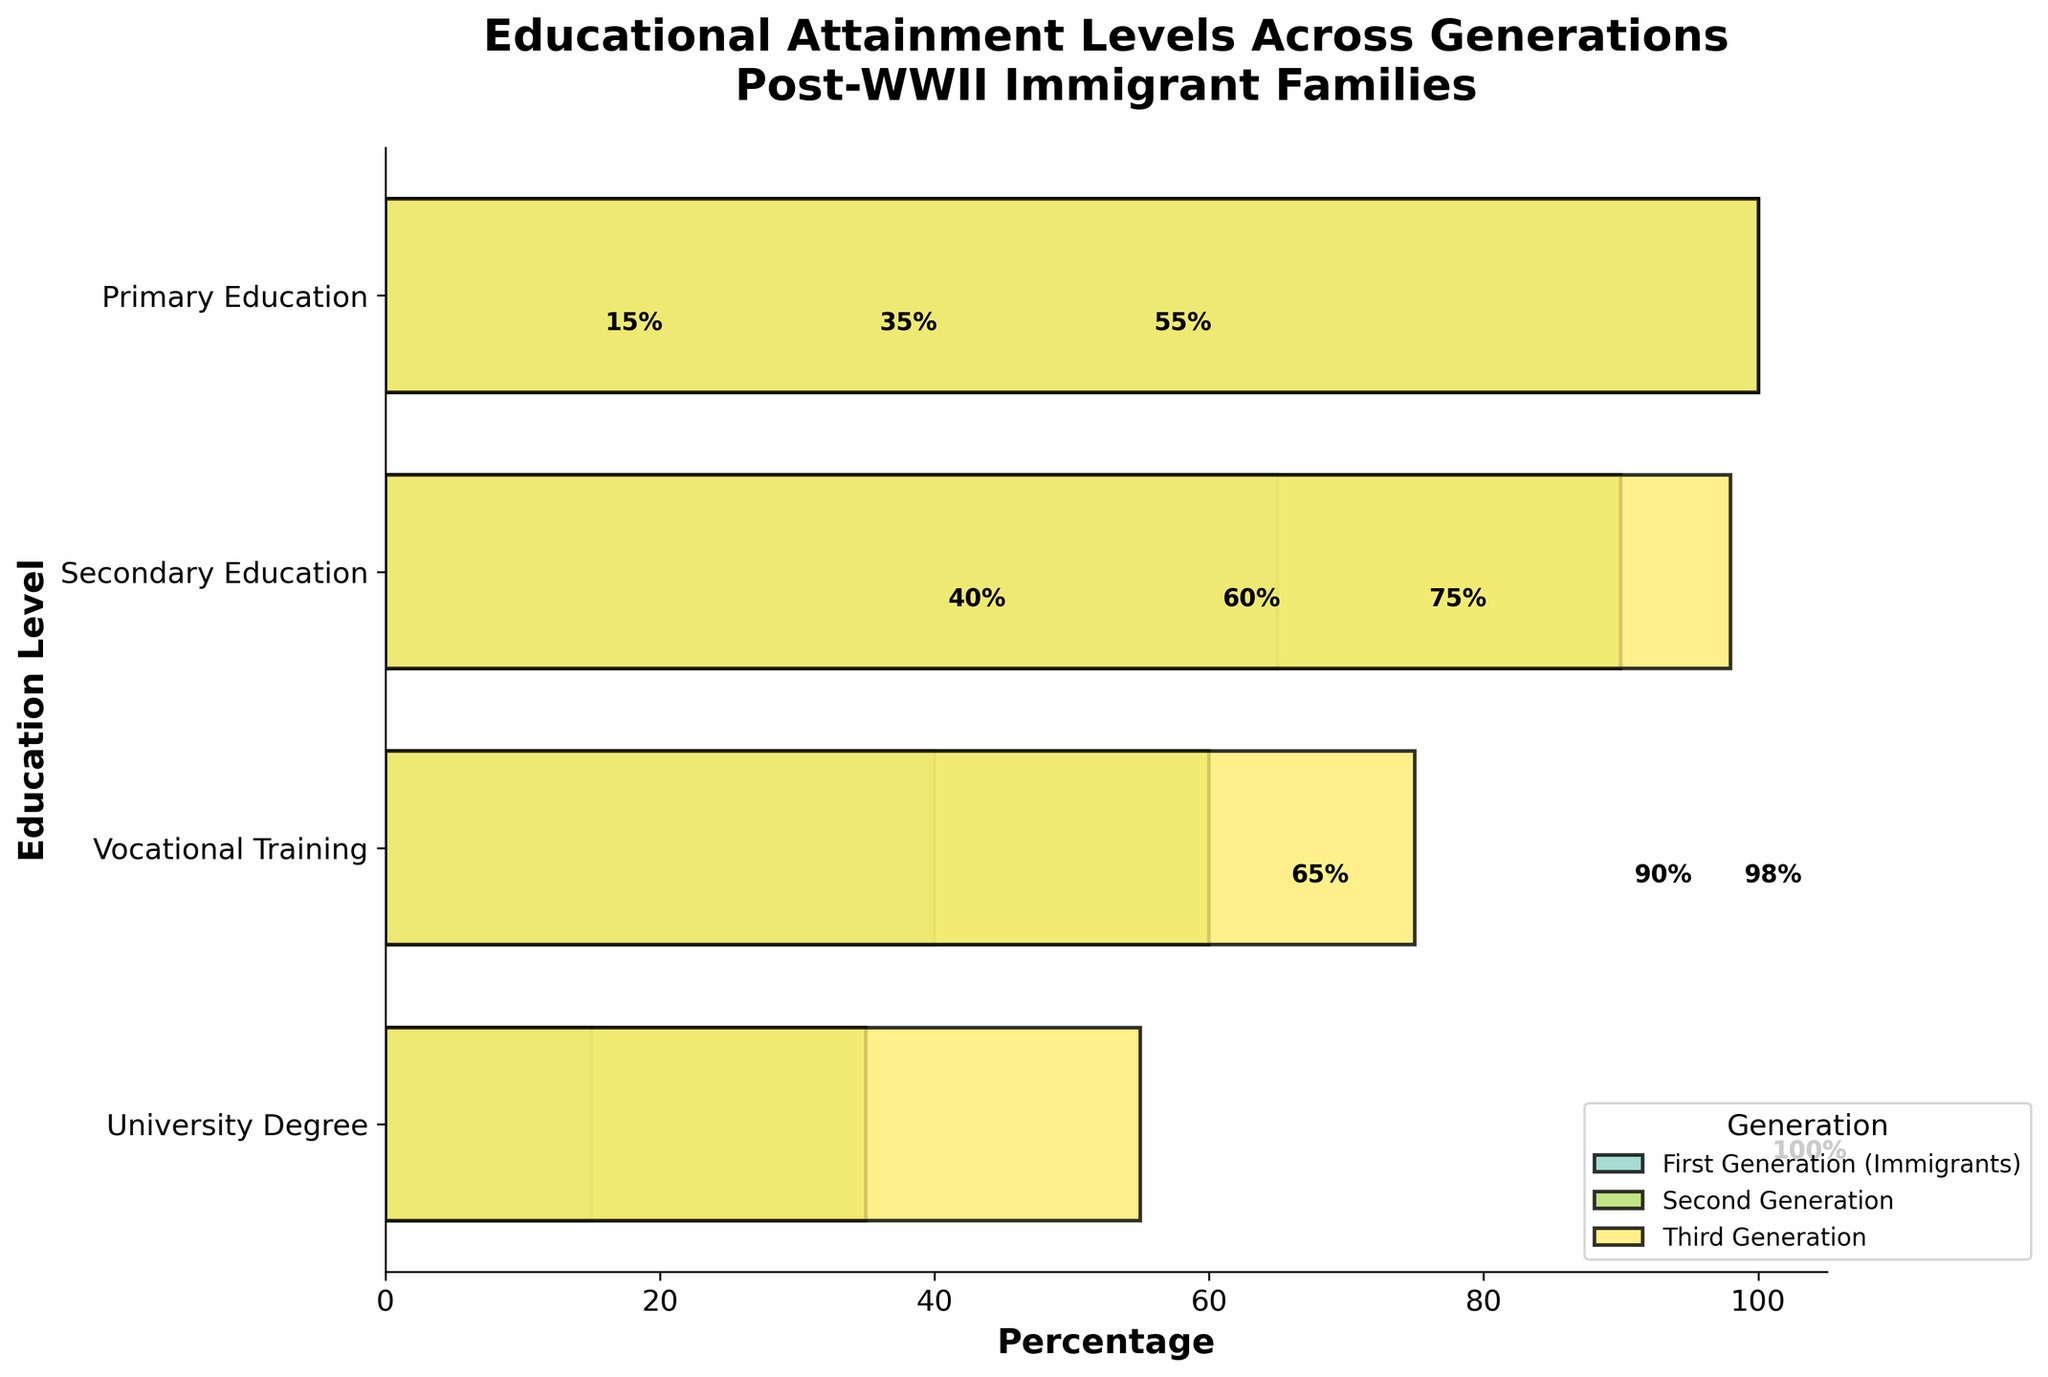what is the title of the figure? The title is usually found at the top of the figure and summarizes the chart's content. In this case, it states the purpose and scope of the data.
Answer: Educational Attainment Levels Across Generations Post-WWII Immigrant Families Which generation has the highest percentage of university degrees? Look at the university degree section of the chart and compare the heights of the bars for different generations.
Answer: Third Generation How much higher is the percentage of secondary education in the Third Generation compared to the First Generation? Subtract the percentage of Secondary Education for the First Generation from that of the Third Generation: 98% - 65% = 33%.
Answer: 33% Which generation shows the most significant improvement in vocational training completion rates compared to the previous generation? Calculate the difference in completion rates for each generation transition: 
1. From First to Second: 60% - 40% = 20%
2. From Second to Third: 75% - 60% = 15%
The largest increase is from First to Second Generation.
Answer: First to Second Generation How does the percentage of primary education compare across all three generations? Observe the primary education section for each generation; they all reach 100%, indicating equal levels of primary education attainment across generations.
Answer: They are equal Which education level shows the most significant decrease from the Second Generation to the First Generation? Compare the percentage drops between the First and Second Generation across all education levels:
1. Secondary Education: 90% - 65% = 25%
2. Vocational Training: 60% - 40% = 20%
3. University Degree: 35% - 15% = 20%
The largest decrease is in Secondary Education.
Answer: Secondary Education Is the percentage of vocational training in the Second Generation greater than the university degree percentage in the Third Generation? Compare the heights of the bars corresponding to vocational training in the Second Generation (60%) and university degrees in the Third Generation (55%).
Answer: Yes Which education level has the smallest change in percentage from the Second to the Third Generation? Calculate the differences for each education level:
1. Primary Education: 100% - 100% = 0%
2. Secondary Education: 98% - 90% = 8%
3. Vocational Training: 75% - 60% = 15%
4. University Degree: 55% - 35% = 20%
The smallest change is in Primary Education (0%).
Answer: Primary Education What is the average percentage of university degree holders across all generations? Sum the university degree percentages and divide by the number of generations: 
(15% + 35% + 55%) / 3 = 105% / 3 = 35%.
Answer: 35% 